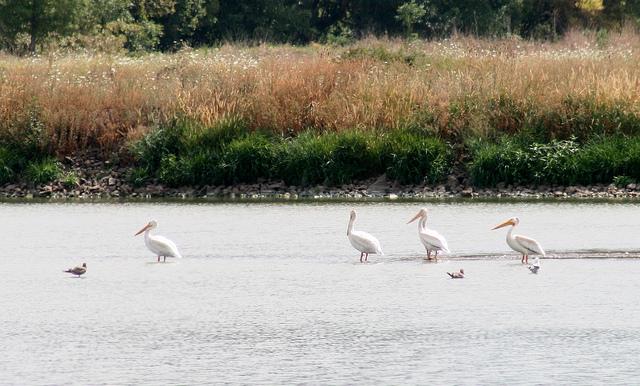How many people?
Give a very brief answer. 0. How many bird are visible?
Keep it brief. 7. What are the big birds called?
Short answer required. Pelicans. Is the water calm?
Write a very short answer. Yes. How many birds are in this water?
Concise answer only. 7. 